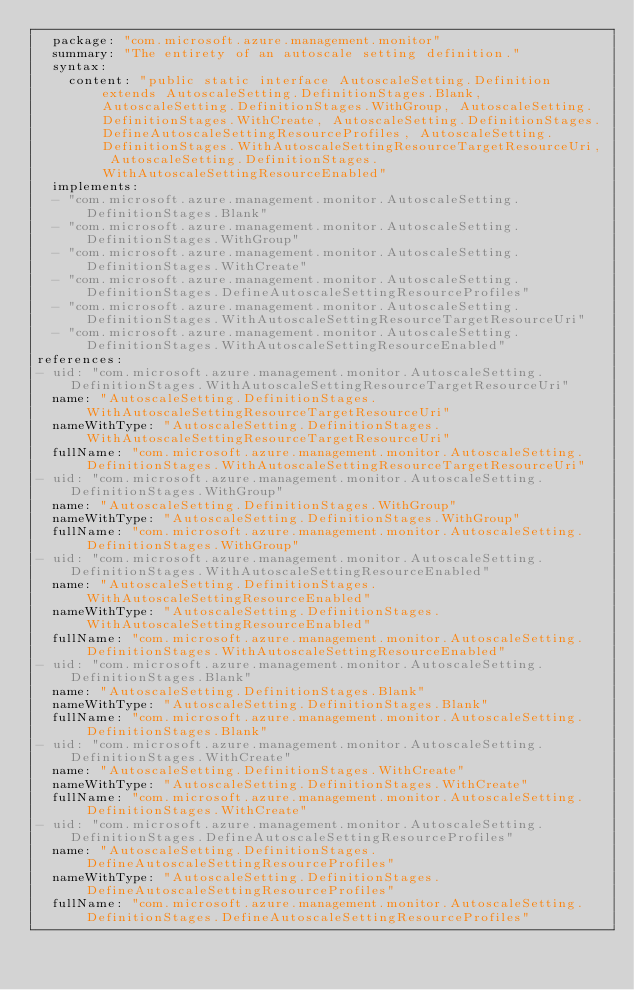Convert code to text. <code><loc_0><loc_0><loc_500><loc_500><_YAML_>  package: "com.microsoft.azure.management.monitor"
  summary: "The entirety of an autoscale setting definition."
  syntax:
    content: "public static interface AutoscaleSetting.Definition extends AutoscaleSetting.DefinitionStages.Blank, AutoscaleSetting.DefinitionStages.WithGroup, AutoscaleSetting.DefinitionStages.WithCreate, AutoscaleSetting.DefinitionStages.DefineAutoscaleSettingResourceProfiles, AutoscaleSetting.DefinitionStages.WithAutoscaleSettingResourceTargetResourceUri, AutoscaleSetting.DefinitionStages.WithAutoscaleSettingResourceEnabled"
  implements:
  - "com.microsoft.azure.management.monitor.AutoscaleSetting.DefinitionStages.Blank"
  - "com.microsoft.azure.management.monitor.AutoscaleSetting.DefinitionStages.WithGroup"
  - "com.microsoft.azure.management.monitor.AutoscaleSetting.DefinitionStages.WithCreate"
  - "com.microsoft.azure.management.monitor.AutoscaleSetting.DefinitionStages.DefineAutoscaleSettingResourceProfiles"
  - "com.microsoft.azure.management.monitor.AutoscaleSetting.DefinitionStages.WithAutoscaleSettingResourceTargetResourceUri"
  - "com.microsoft.azure.management.monitor.AutoscaleSetting.DefinitionStages.WithAutoscaleSettingResourceEnabled"
references:
- uid: "com.microsoft.azure.management.monitor.AutoscaleSetting.DefinitionStages.WithAutoscaleSettingResourceTargetResourceUri"
  name: "AutoscaleSetting.DefinitionStages.WithAutoscaleSettingResourceTargetResourceUri"
  nameWithType: "AutoscaleSetting.DefinitionStages.WithAutoscaleSettingResourceTargetResourceUri"
  fullName: "com.microsoft.azure.management.monitor.AutoscaleSetting.DefinitionStages.WithAutoscaleSettingResourceTargetResourceUri"
- uid: "com.microsoft.azure.management.monitor.AutoscaleSetting.DefinitionStages.WithGroup"
  name: "AutoscaleSetting.DefinitionStages.WithGroup"
  nameWithType: "AutoscaleSetting.DefinitionStages.WithGroup"
  fullName: "com.microsoft.azure.management.monitor.AutoscaleSetting.DefinitionStages.WithGroup"
- uid: "com.microsoft.azure.management.monitor.AutoscaleSetting.DefinitionStages.WithAutoscaleSettingResourceEnabled"
  name: "AutoscaleSetting.DefinitionStages.WithAutoscaleSettingResourceEnabled"
  nameWithType: "AutoscaleSetting.DefinitionStages.WithAutoscaleSettingResourceEnabled"
  fullName: "com.microsoft.azure.management.monitor.AutoscaleSetting.DefinitionStages.WithAutoscaleSettingResourceEnabled"
- uid: "com.microsoft.azure.management.monitor.AutoscaleSetting.DefinitionStages.Blank"
  name: "AutoscaleSetting.DefinitionStages.Blank"
  nameWithType: "AutoscaleSetting.DefinitionStages.Blank"
  fullName: "com.microsoft.azure.management.monitor.AutoscaleSetting.DefinitionStages.Blank"
- uid: "com.microsoft.azure.management.monitor.AutoscaleSetting.DefinitionStages.WithCreate"
  name: "AutoscaleSetting.DefinitionStages.WithCreate"
  nameWithType: "AutoscaleSetting.DefinitionStages.WithCreate"
  fullName: "com.microsoft.azure.management.monitor.AutoscaleSetting.DefinitionStages.WithCreate"
- uid: "com.microsoft.azure.management.monitor.AutoscaleSetting.DefinitionStages.DefineAutoscaleSettingResourceProfiles"
  name: "AutoscaleSetting.DefinitionStages.DefineAutoscaleSettingResourceProfiles"
  nameWithType: "AutoscaleSetting.DefinitionStages.DefineAutoscaleSettingResourceProfiles"
  fullName: "com.microsoft.azure.management.monitor.AutoscaleSetting.DefinitionStages.DefineAutoscaleSettingResourceProfiles"
</code> 